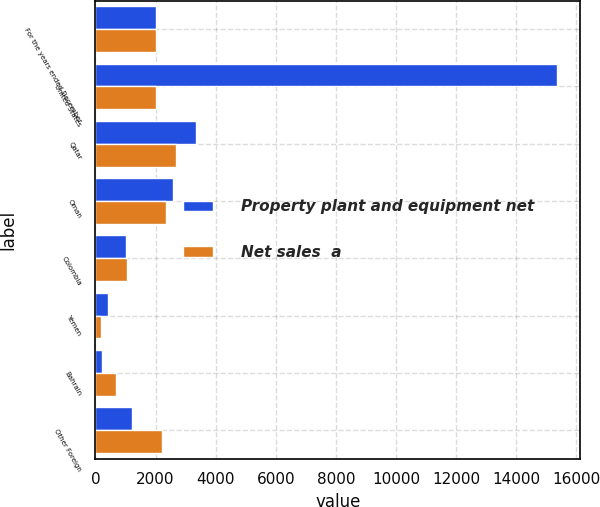Convert chart to OTSL. <chart><loc_0><loc_0><loc_500><loc_500><stacked_bar_chart><ecel><fcel>For the years ended December<fcel>United States<fcel>Qatar<fcel>Oman<fcel>Colombia<fcel>Yemen<fcel>Bahrain<fcel>Other Foreign<nl><fcel>Property plant and equipment net<fcel>2012<fcel>15359<fcel>3356<fcel>2578<fcel>1027<fcel>407<fcel>215<fcel>1230<nl><fcel>Net sales  a<fcel>2012<fcel>2012<fcel>2676<fcel>2353<fcel>1041<fcel>199<fcel>688<fcel>2217<nl></chart> 